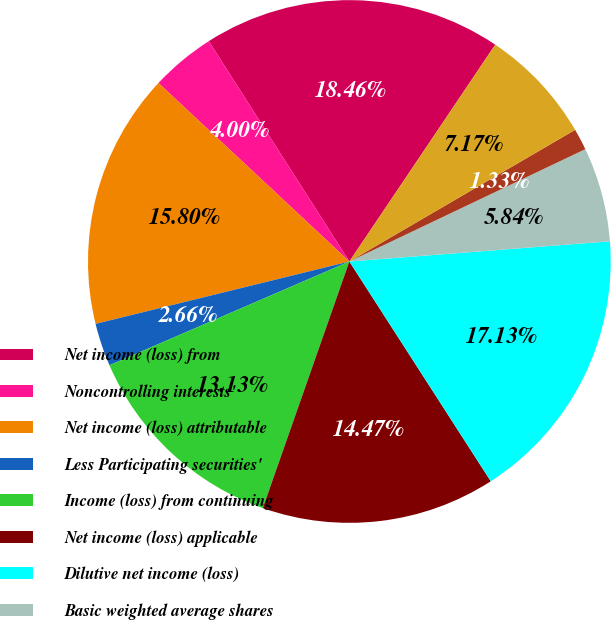<chart> <loc_0><loc_0><loc_500><loc_500><pie_chart><fcel>Net income (loss) from<fcel>Noncontrolling interests'<fcel>Net income (loss) attributable<fcel>Less Participating securities'<fcel>Income (loss) from continuing<fcel>Net income (loss) applicable<fcel>Dilutive net income (loss)<fcel>Basic weighted average shares<fcel>Dilutive potential common<fcel>Diluted weighted average<nl><fcel>18.46%<fcel>4.0%<fcel>15.8%<fcel>2.66%<fcel>13.13%<fcel>14.47%<fcel>17.13%<fcel>5.84%<fcel>1.33%<fcel>7.17%<nl></chart> 